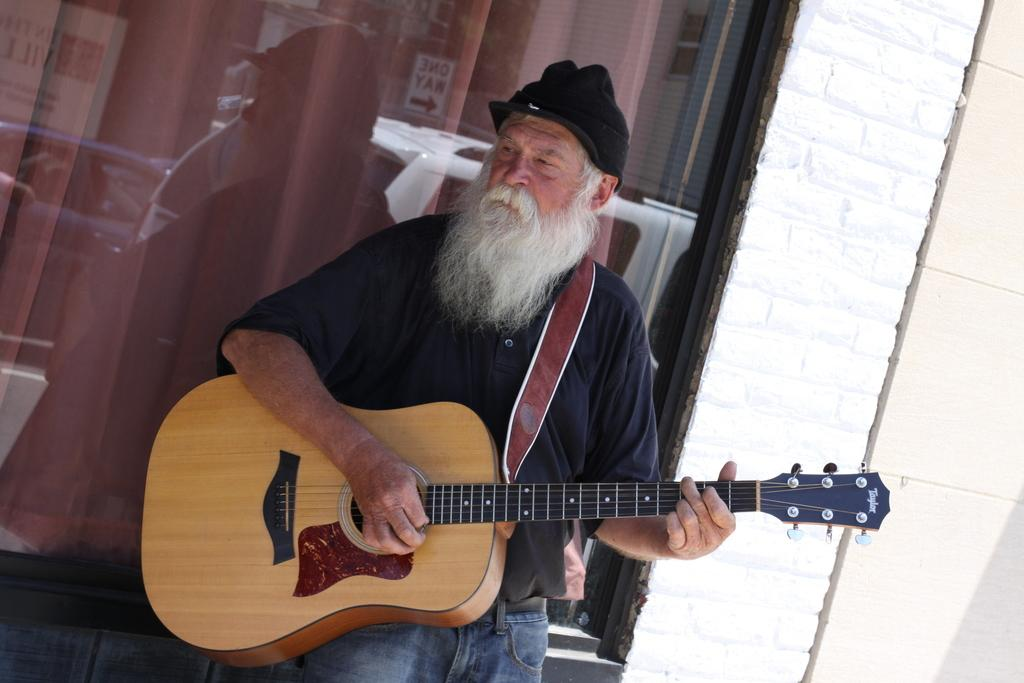What is the man in the image doing? The man is playing a guitar. What is the man wearing in the image? The man is wearing a black t-shirt. Can you describe the reflection visible in the image? There is a reflection of vehicles on a glass surface in the image. What color is the base of the guitar in the image? There is no mention of a base or the color of the guitar in the provided facts. 